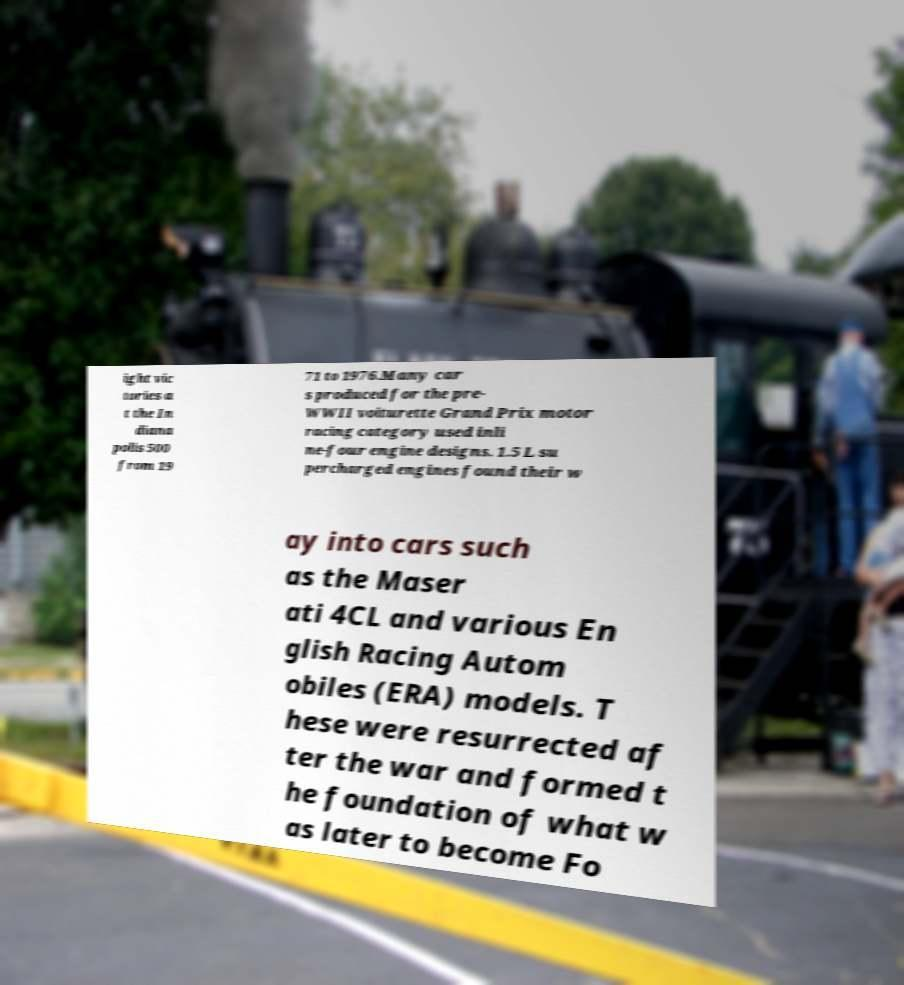Could you extract and type out the text from this image? ight vic tories a t the In diana polis 500 from 19 71 to 1976.Many car s produced for the pre- WWII voiturette Grand Prix motor racing category used inli ne-four engine designs. 1.5 L su percharged engines found their w ay into cars such as the Maser ati 4CL and various En glish Racing Autom obiles (ERA) models. T hese were resurrected af ter the war and formed t he foundation of what w as later to become Fo 